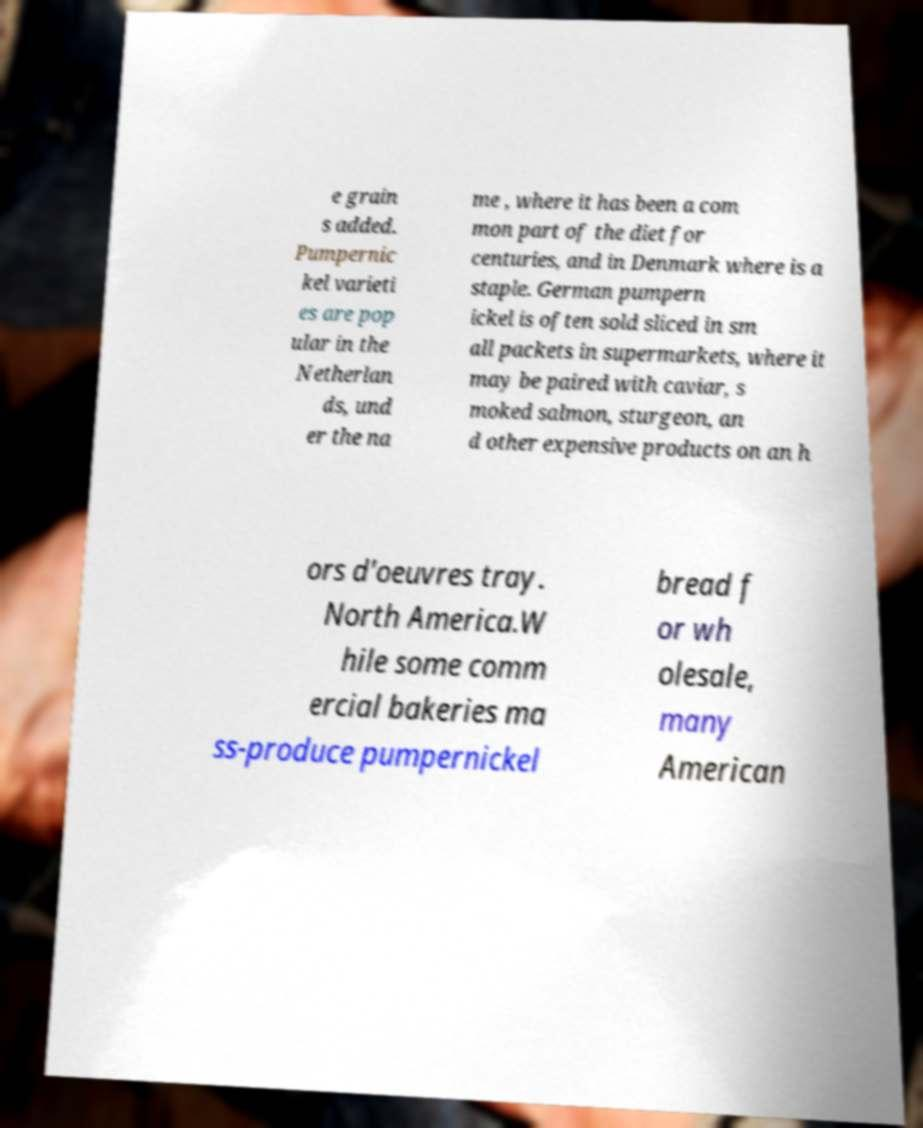Please read and relay the text visible in this image. What does it say? e grain s added. Pumpernic kel varieti es are pop ular in the Netherlan ds, und er the na me , where it has been a com mon part of the diet for centuries, and in Denmark where is a staple. German pumpern ickel is often sold sliced in sm all packets in supermarkets, where it may be paired with caviar, s moked salmon, sturgeon, an d other expensive products on an h ors d'oeuvres tray. North America.W hile some comm ercial bakeries ma ss-produce pumpernickel bread f or wh olesale, many American 